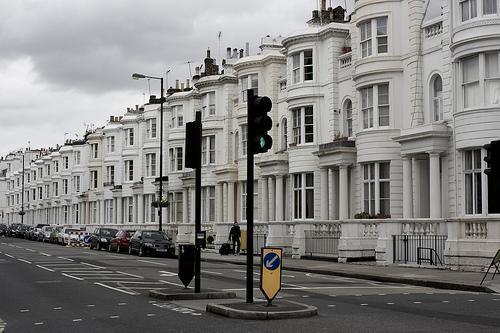How many people are walking on the sidewalk?
Give a very brief answer. 1. How many above-grade stories does each building have?
Give a very brief answer. 3. 